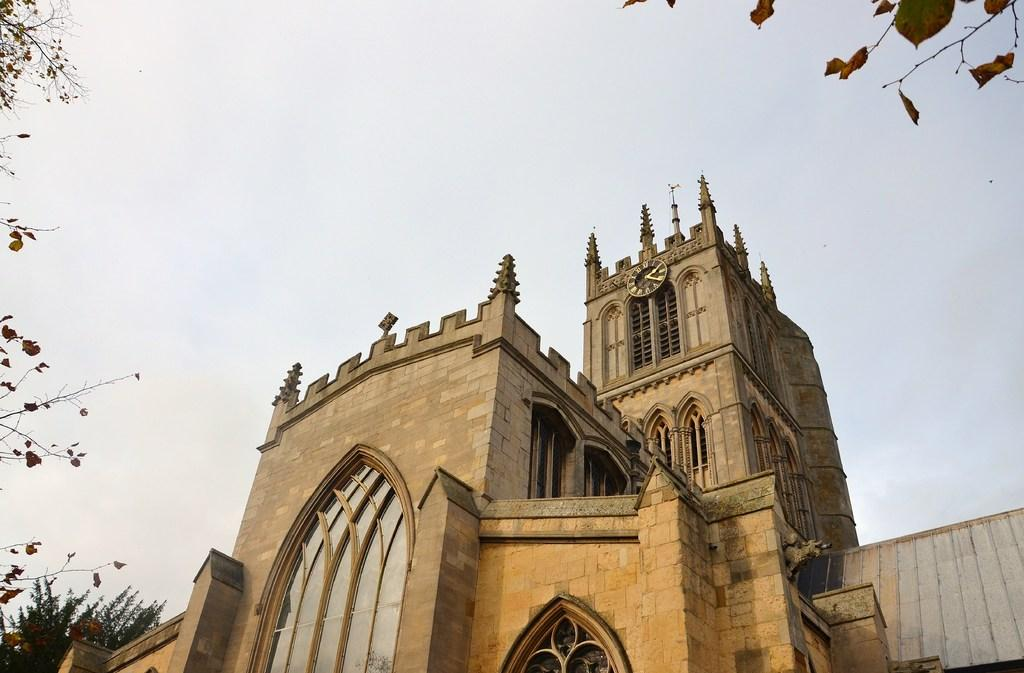What type of structure is present in the image? There is a building in the image. What can be seen on the left side of the image? There are trees on the left side of the image. What is present on the top right side of the image? There are leaves on the top right side of the image. What is visible in the background of the image? The sky is visible in the image. What type of coat is hanging on the tree in the image? There is no coat present in the image; it features a building, trees, leaves, and the sky. 